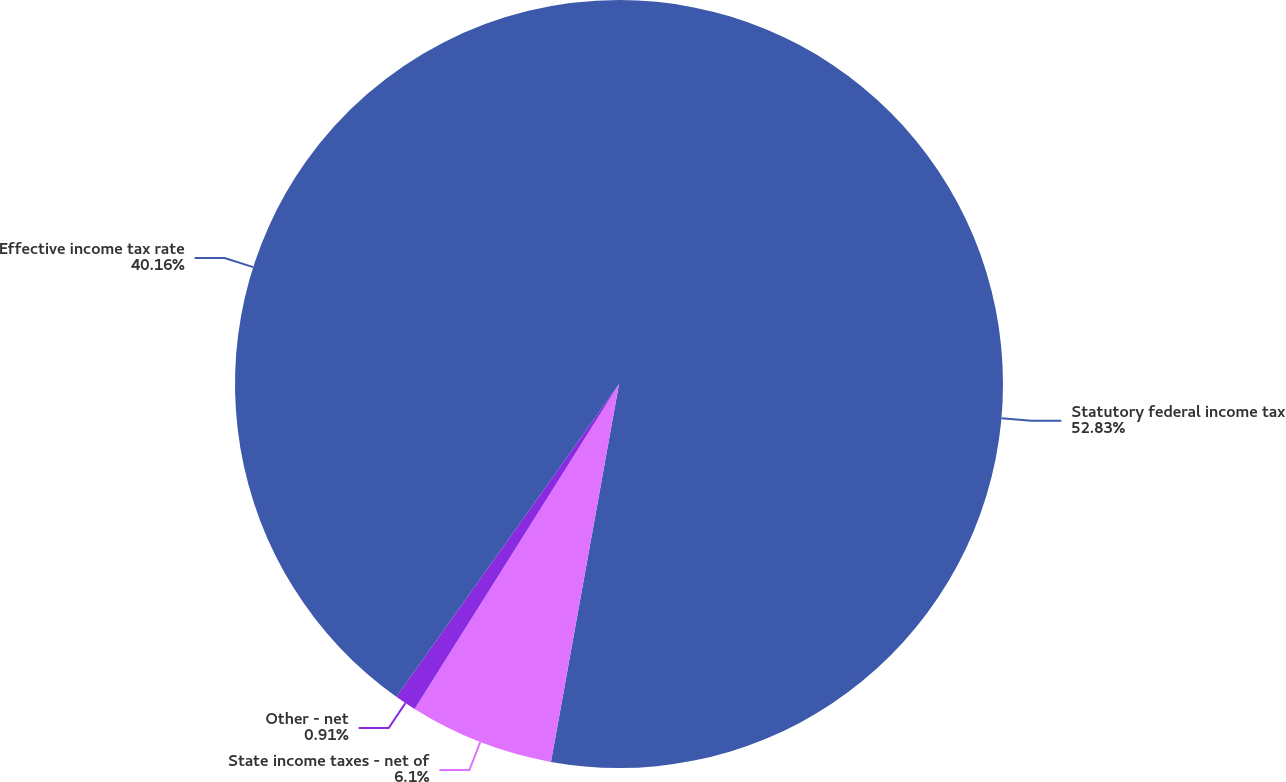Convert chart to OTSL. <chart><loc_0><loc_0><loc_500><loc_500><pie_chart><fcel>Statutory federal income tax<fcel>State income taxes - net of<fcel>Other - net<fcel>Effective income tax rate<nl><fcel>52.84%<fcel>6.1%<fcel>0.91%<fcel>40.16%<nl></chart> 